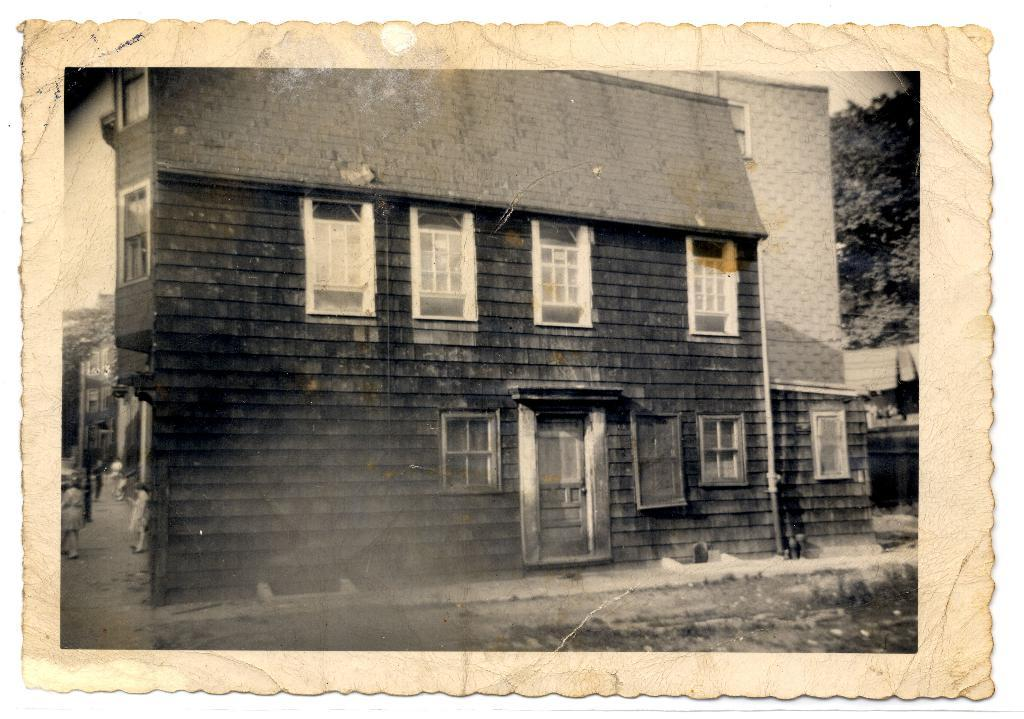What is the main subject of the image? There is a photograph in the image. What can be seen in the photograph? There are people on the road in the image. What type of structure is visible in the image? There is a building visible in the image. What type of vegetation is present in the image? There are trees in the image. What type of pancake is being served at the restaurant in the image? There is no restaurant or pancake present in the image; it features a photograph of people on the road. 